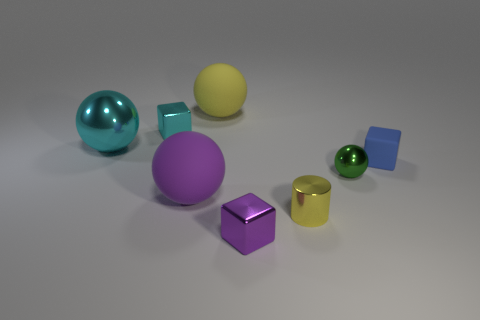How would you describe the composition of the objects? The objects are arranged in an asymmetric composition that seems casual but balanced, with a mixture of spherical and cuboid shapes scattered across the surface. 